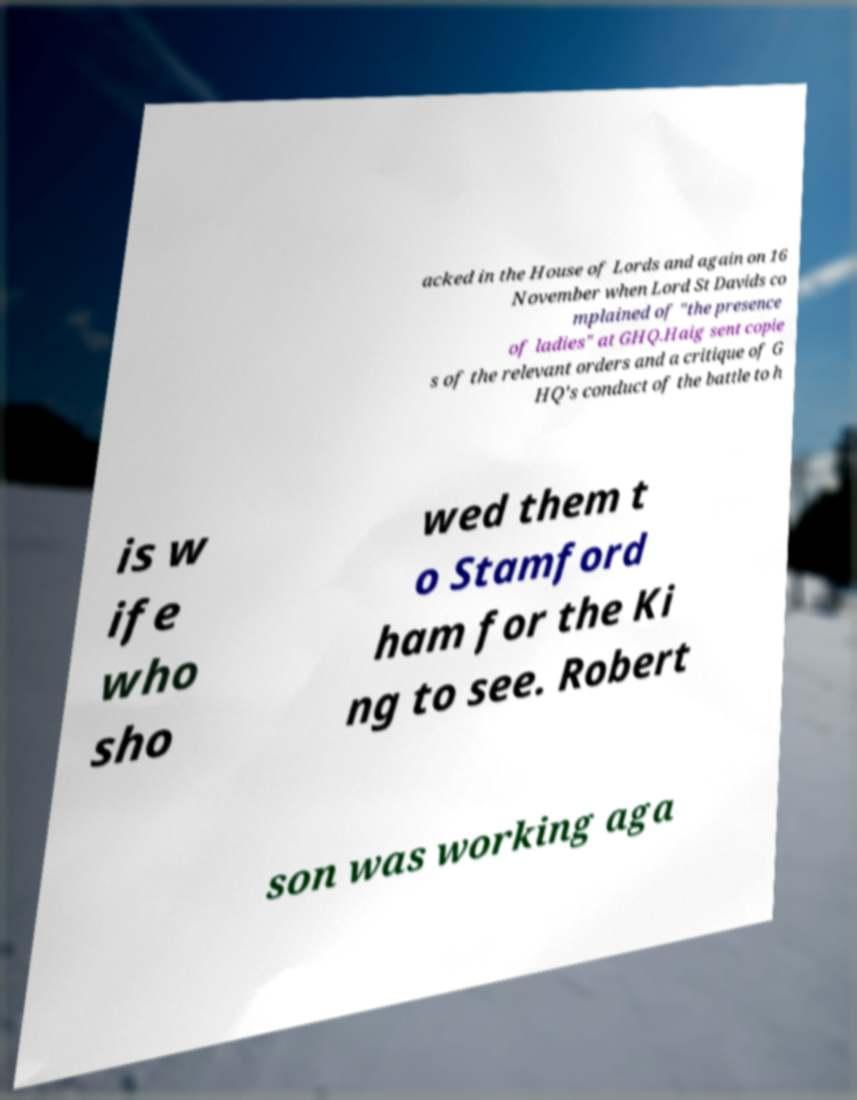Can you accurately transcribe the text from the provided image for me? acked in the House of Lords and again on 16 November when Lord St Davids co mplained of "the presence of ladies" at GHQ.Haig sent copie s of the relevant orders and a critique of G HQ's conduct of the battle to h is w ife who sho wed them t o Stamford ham for the Ki ng to see. Robert son was working aga 